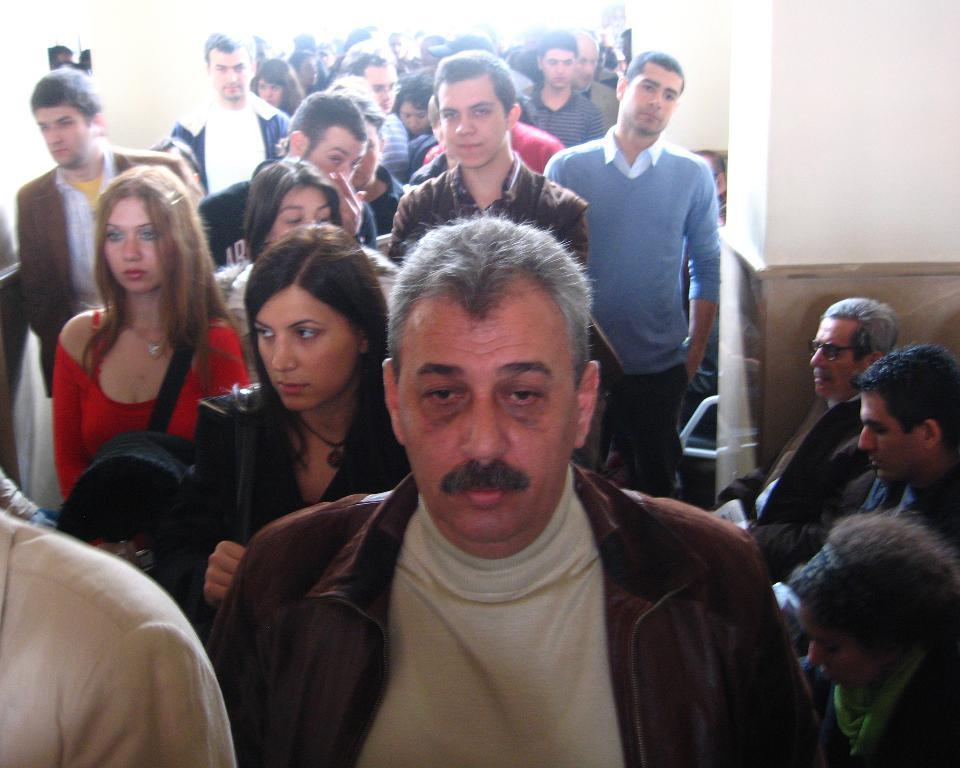What are the people in the image doing? The people in the image are walking. What can be seen on the right side of the image? There is a pillar on the right side of the image. Are there any people sitting in the image? Yes, there are people sitting on chairs near the pillar. Reasoning: Let'g: Let's think step by step in order to produce the conversation. We start by identifying the main action of the people in the image, which is walking. Then, we describe the pillar on the right side of the image, as it is a prominent feature. Finally, we mention the people sitting on chairs near the pillar, providing additional information about the scene. Absurd Question/Answer: What type of lumber is being used to construct the sink in the image? There is no sink or lumber present in the image. Is there a volcanic activity visible in the image? No, there is no volcanic activity or volcano present in the image. 